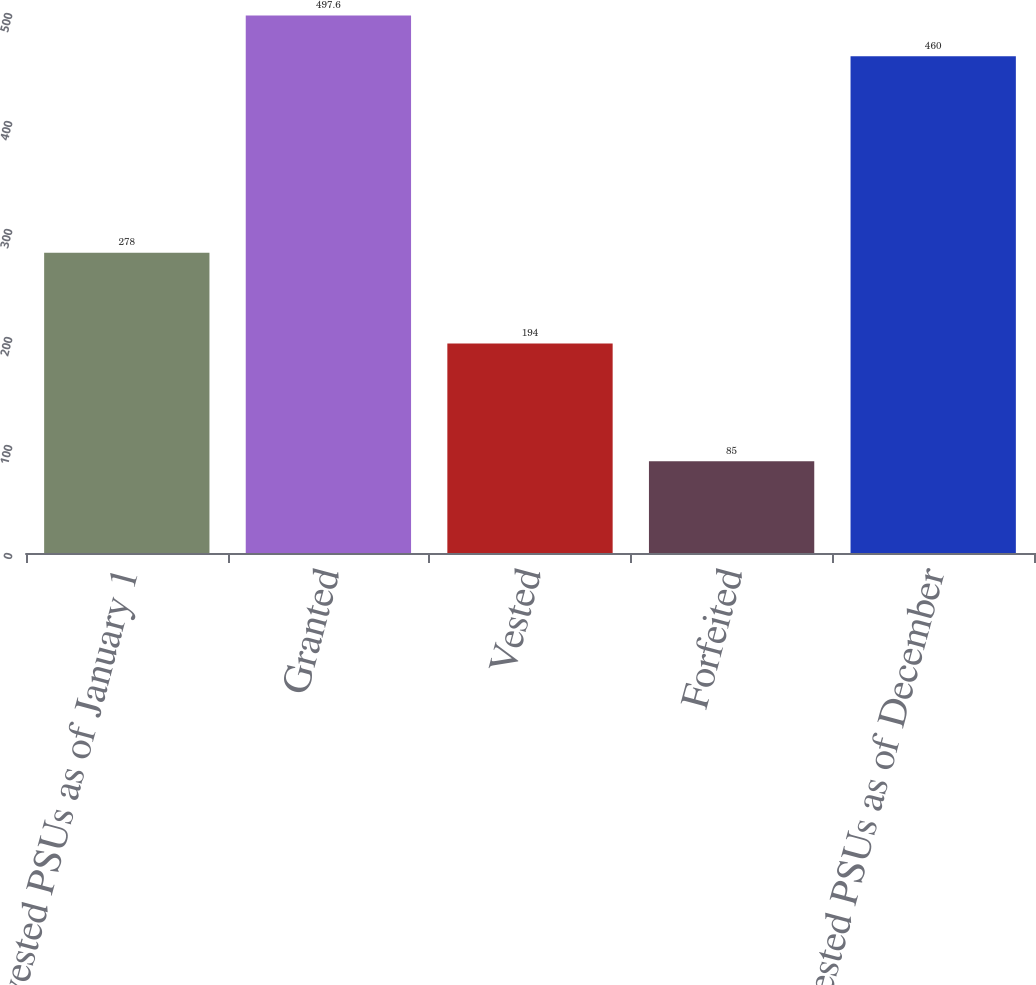<chart> <loc_0><loc_0><loc_500><loc_500><bar_chart><fcel>Nonvested PSUs as of January 1<fcel>Granted<fcel>Vested<fcel>Forfeited<fcel>Nonvested PSUs as of December<nl><fcel>278<fcel>497.6<fcel>194<fcel>85<fcel>460<nl></chart> 